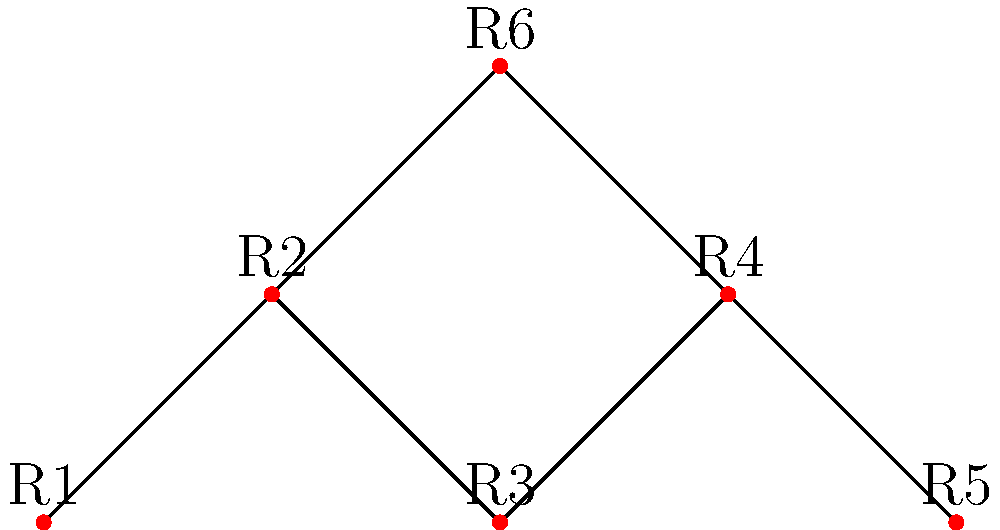In a city known for its culinary excellence, six Michelin-starred restaurants (R1 to R6) form a network as shown in the diagram. Each edge represents a direct transportation route between two restaurants. As a conductor planning a gastronomic tour for your orchestra, you need to determine the connectivity of this network. What is the minimum number of restaurants that need to be closed to disconnect the network completely (i.e., make it impossible to travel between any two remaining restaurants)? To solve this problem, we need to analyze the graph's connectivity and find its minimum vertex cut set. Let's approach this step-by-step:

1. Observe the graph structure:
   - We have 6 vertices (restaurants) labeled R1 to R6.
   - The edges form a path R1--R2--R3--R4--R5 and two additional connections R2--R6 and R4--R6.

2. Identify critical vertices:
   - R2 and R4 are the most connected vertices, each with three edges.
   - R6 connects to both R2 and R4, forming a triangle.

3. Consider possible cut sets:
   - Removing R2 and R4 would disconnect R1, R3, and R5 from each other and from R6.
   - Removing R1, R3, and R5 would not disconnect the network as R2, R4, and R6 would still be connected.
   - Removing R6 alone would not disconnect the network.

4. Verify the minimum cut set:
   - Removing only R2 or only R4 is not sufficient to disconnect the network completely.
   - Removing both R2 and R4 is the minimum number of vertices needed to disconnect the graph.

5. Conclusion:
   The minimum number of restaurants that need to be closed to disconnect the network is 2, specifically R2 and R4.

This solution ensures that no path exists between any two remaining restaurants, effectively disconnecting the culinary network.
Answer: 2 